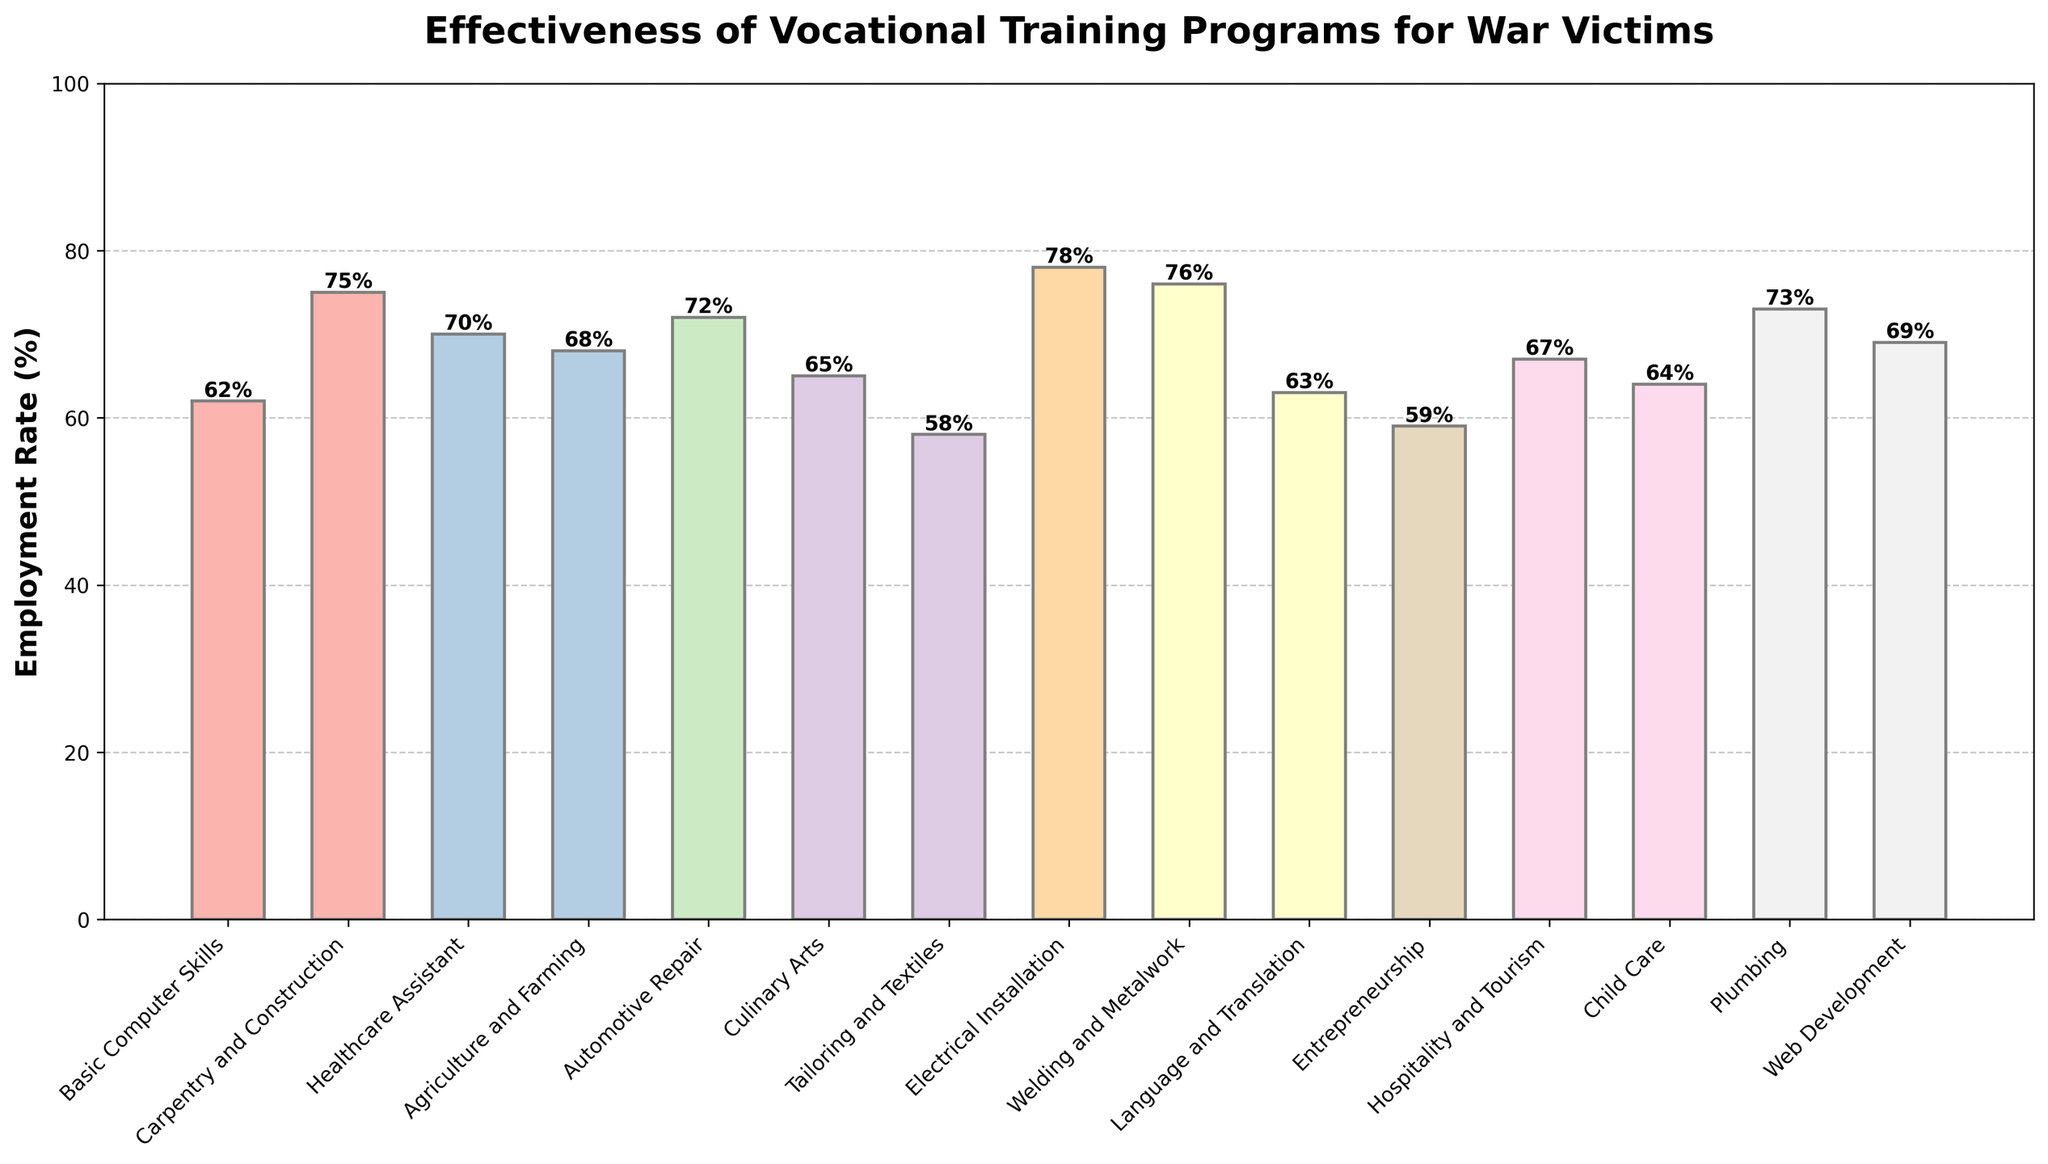which vocational training program has the highest employment rate? The bar representing "Electrical Installation" reaches the highest level on the y-axis, indicating it has the highest employment rate among all the programs.
Answer: Electrical Installation which two vocational training programs have employment rates closest to 70%? From the figure, the bars representing "Healthcare Assistant" at 70% and "Web Development" at 69% are the closest to 70%.
Answer: Healthcare Assistant and Web Development what is the difference between the highest and lowest employment rates? The highest employment rate is 78% (Electrical Installation) and the lowest is 58% (Tailoring and Textiles). The difference is 78 - 58 = 20%.
Answer: 20% which programs have employment rates above 70%? The bars reaching above the 70% line represent "Carpentry and Construction," "Automotive Repair," "Electrical Installation," "Welding and Metalwork," and "Plumbing."
Answer: Carpentry and Construction, Automotive Repair, Electrical Installation, Welding and Metalwork, and Plumbing what is the average employment rate for all programs? Add all the employment rates: 62 + 75 + 70 + 68 + 72 + 65 + 58 + 78 + 76 + 63 + 59 + 67 + 64 + 73 + 69 = 1019. Divide by the number of programs (15): 1019 / 15 ≈ 67.93%.
Answer: 67.93% how does the employment rate of "Culinary Arts" compare to "Hospitality and Tourism"? Visually comparing the heights of the bars, the "Culinary Arts" bar is shorter than the "Hospitality and Tourism" bar. "Culinary Arts" has an employment rate of 65% while "Hospitality and Tourism" has 67%.
Answer: Culinary Arts is lower by 2% is the employment rate of "Child Care" higher than the average employment rate for all programs? The average employment rate is 67.93%. The employment rate for "Child Care" is 64%, which is lower than the average.
Answer: No if you sum the employment rates of the top three programs, what is the result? The top three programs are Electrical Installation (78%), Welding and Metalwork (76%), and Carpentry and Construction (75%). The sum is 78 + 76 + 75 = 229%.
Answer: 229% which program has an employment rate just above "Language and Translation"? The bar for "Language and Translation" is at 63%. The next higher bars are for "Child Care" at 64% and "Healthcare Assistant" at 70%.
Answer: Child Care in terms of employment rates, which two programs are the most similar? "Carpentry and Construction" at 75% and "Welding and Metalwork" at 76% have bars of nearly identical heights, indicating the most similar employment rates.
Answer: Carpentry and Construction and Welding and Metalwork 